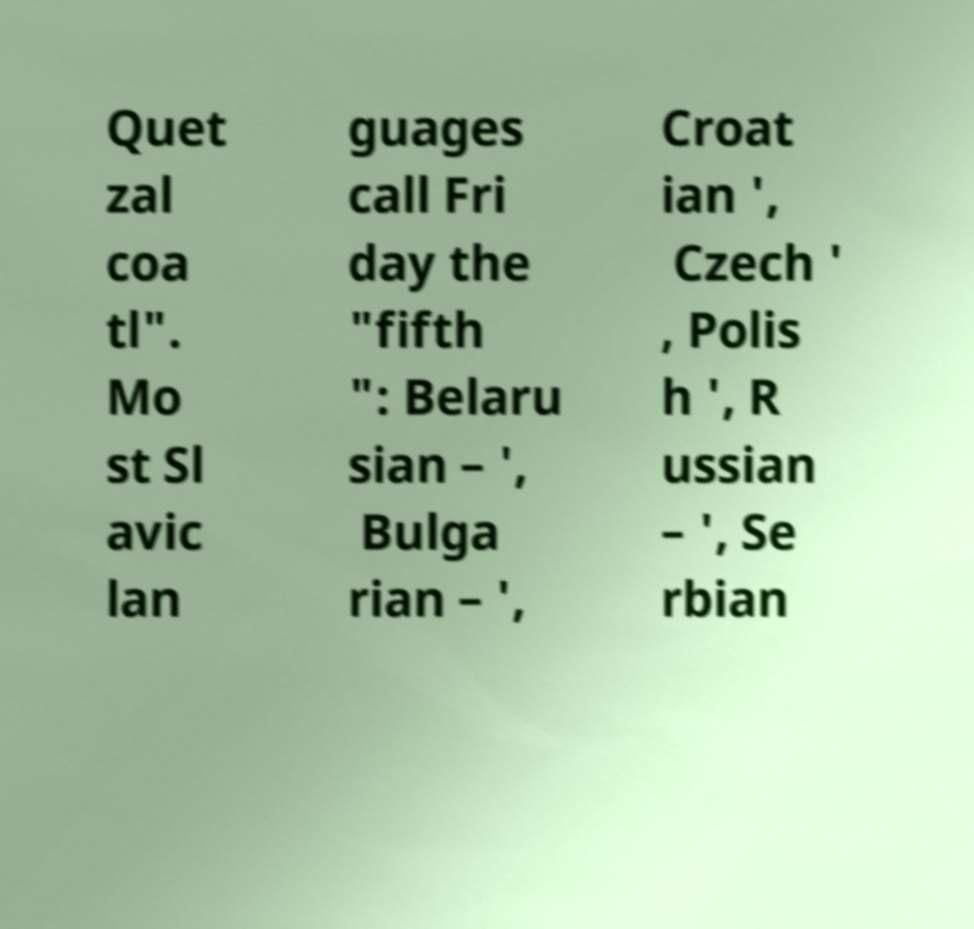I need the written content from this picture converted into text. Can you do that? Quet zal coa tl". Mo st Sl avic lan guages call Fri day the "fifth ": Belaru sian – ', Bulga rian – ', Croat ian ', Czech ' , Polis h ', R ussian – ', Se rbian 